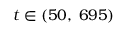<formula> <loc_0><loc_0><loc_500><loc_500>t \in ( 5 0 , \, 6 9 5 )</formula> 